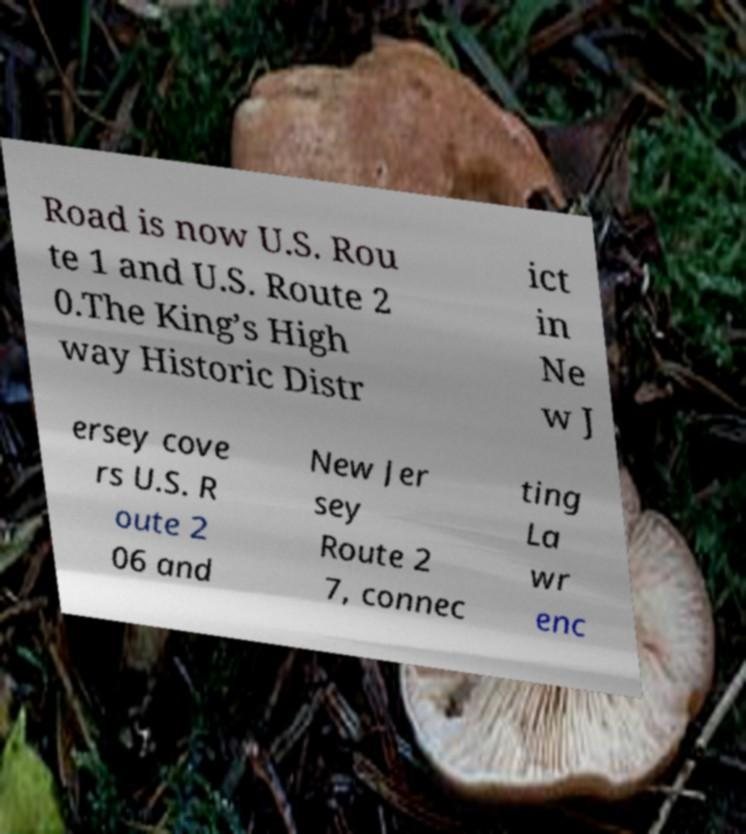Could you extract and type out the text from this image? Road is now U.S. Rou te 1 and U.S. Route 2 0.The King’s High way Historic Distr ict in Ne w J ersey cove rs U.S. R oute 2 06 and New Jer sey Route 2 7, connec ting La wr enc 